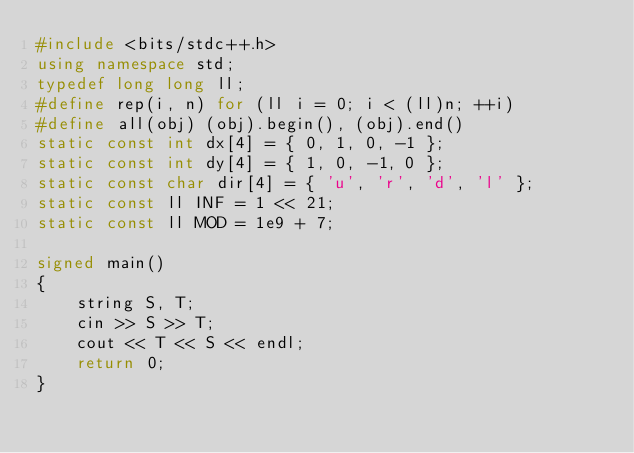Convert code to text. <code><loc_0><loc_0><loc_500><loc_500><_C++_>#include <bits/stdc++.h>
using namespace std;
typedef long long ll;
#define rep(i, n) for (ll i = 0; i < (ll)n; ++i)
#define all(obj) (obj).begin(), (obj).end()
static const int dx[4] = { 0, 1, 0, -1 };
static const int dy[4] = { 1, 0, -1, 0 };
static const char dir[4] = { 'u', 'r', 'd', 'l' };
static const ll INF = 1 << 21;
static const ll MOD = 1e9 + 7;

signed main()
{
    string S, T;
    cin >> S >> T;
    cout << T << S << endl;
    return 0;
}</code> 